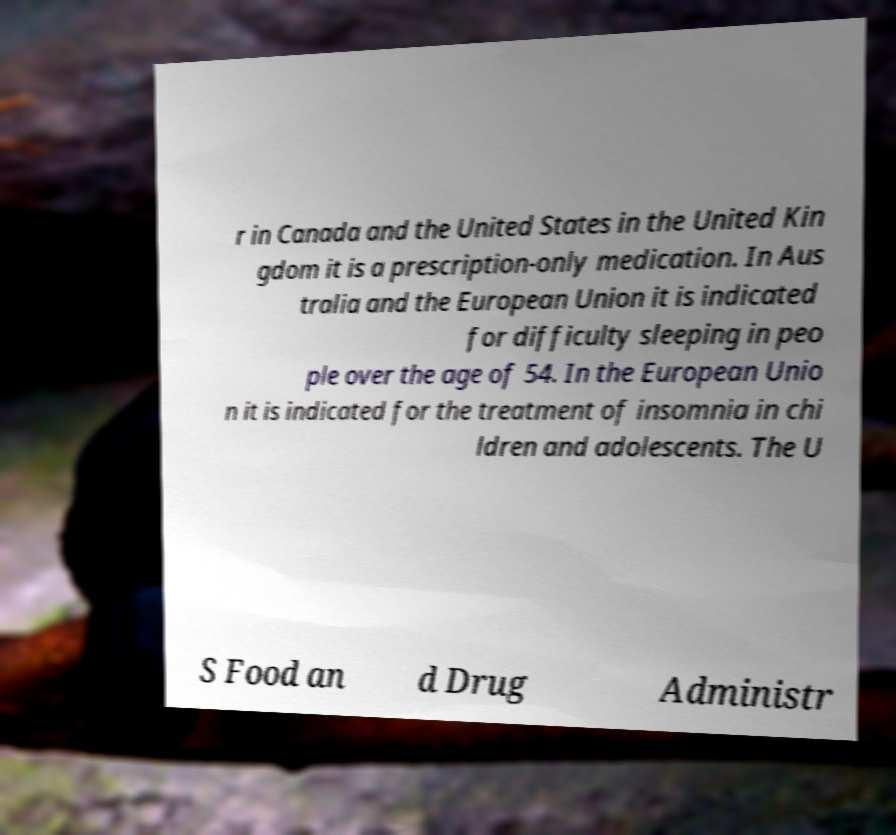Please identify and transcribe the text found in this image. r in Canada and the United States in the United Kin gdom it is a prescription-only medication. In Aus tralia and the European Union it is indicated for difficulty sleeping in peo ple over the age of 54. In the European Unio n it is indicated for the treatment of insomnia in chi ldren and adolescents. The U S Food an d Drug Administr 